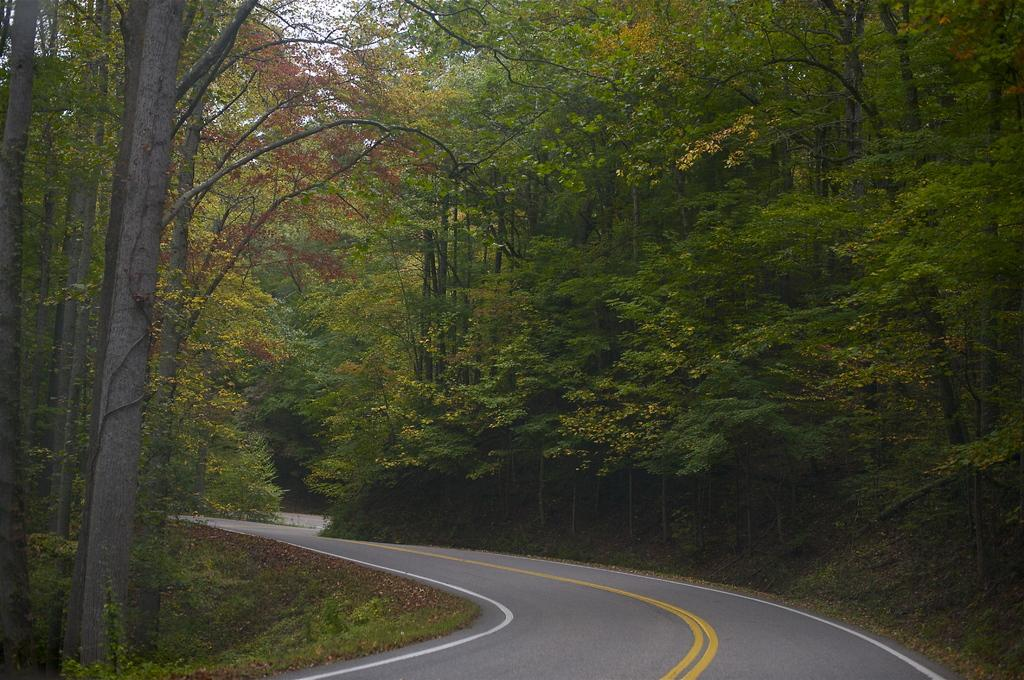What is located in front of the image? There is a road in front of the image. What can be seen beside the road? Dry leaves and grass are present beside the road. What type of vegetation is present beside the road? Plants are present beside the road. Where is the crowd gathered in the image? There is no crowd present in the image. What type of plastic object can be seen in the image? There is no plastic object present in the image. 